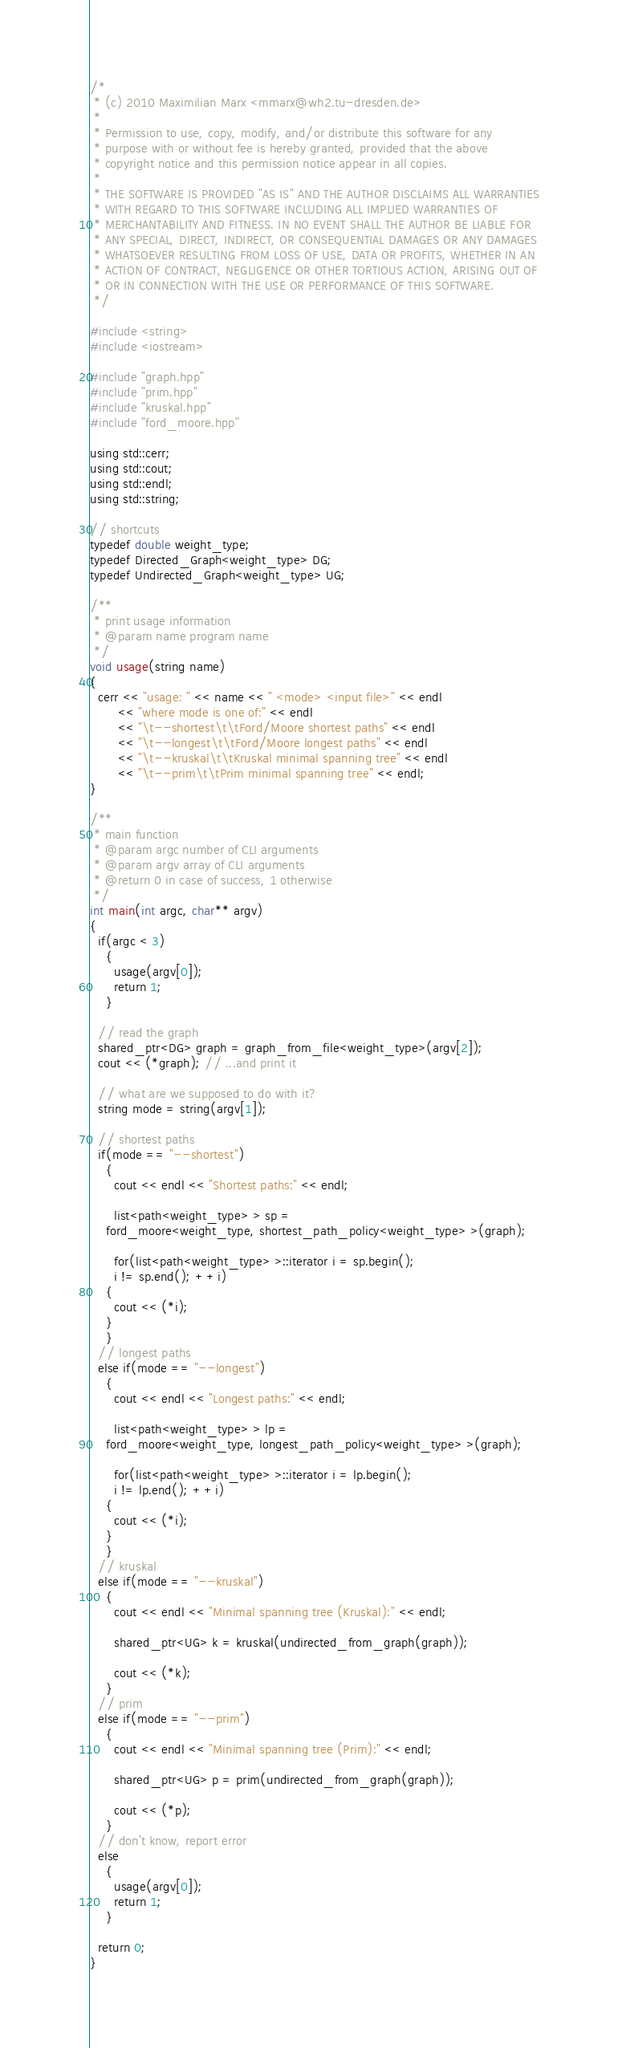<code> <loc_0><loc_0><loc_500><loc_500><_C++_>/*
 * (c) 2010 Maximilian Marx <mmarx@wh2.tu-dresden.de>
 *
 * Permission to use, copy, modify, and/or distribute this software for any
 * purpose with or without fee is hereby granted, provided that the above
 * copyright notice and this permission notice appear in all copies.
 *
 * THE SOFTWARE IS PROVIDED "AS IS" AND THE AUTHOR DISCLAIMS ALL WARRANTIES
 * WITH REGARD TO THIS SOFTWARE INCLUDING ALL IMPLIED WARRANTIES OF
 * MERCHANTABILITY AND FITNESS. IN NO EVENT SHALL THE AUTHOR BE LIABLE FOR
 * ANY SPECIAL, DIRECT, INDIRECT, OR CONSEQUENTIAL DAMAGES OR ANY DAMAGES
 * WHATSOEVER RESULTING FROM LOSS OF USE, DATA OR PROFITS, WHETHER IN AN
 * ACTION OF CONTRACT, NEGLIGENCE OR OTHER TORTIOUS ACTION, ARISING OUT OF
 * OR IN CONNECTION WITH THE USE OR PERFORMANCE OF THIS SOFTWARE.
 */

#include <string>
#include <iostream>

#include "graph.hpp"
#include "prim.hpp"
#include "kruskal.hpp"
#include "ford_moore.hpp"

using std::cerr;
using std::cout;
using std::endl;
using std::string;

// shortcuts
typedef double weight_type;
typedef Directed_Graph<weight_type> DG;
typedef Undirected_Graph<weight_type> UG;

/**
 * print usage information
 * @param name program name
 */
void usage(string name)
{
  cerr << "usage: " << name << " <mode> <input file>" << endl
       << "where mode is one of:" << endl
       << "\t--shortest\t\tFord/Moore shortest paths" << endl
       << "\t--longest\t\tFord/Moore longest paths" << endl
       << "\t--kruskal\t\tKruskal minimal spanning tree" << endl
       << "\t--prim\t\tPrim minimal spanning tree" << endl;
}

/**
 * main function
 * @param argc number of CLI arguments
 * @param argv array of CLI arguments
 * @return 0 in case of success, 1 otherwise
 */
int main(int argc, char** argv)
{
  if(argc < 3)
    {
      usage(argv[0]);
      return 1;
    }

  // read the graph
  shared_ptr<DG> graph = graph_from_file<weight_type>(argv[2]);
  cout << (*graph); // ...and print it

  // what are we supposed to do with it?
  string mode = string(argv[1]);

  // shortest paths
  if(mode == "--shortest")
    {
      cout << endl << "Shortest paths:" << endl;

      list<path<weight_type> > sp =
	ford_moore<weight_type, shortest_path_policy<weight_type> >(graph);

      for(list<path<weight_type> >::iterator i = sp.begin();
	  i != sp.end(); ++i)
	{
	  cout << (*i);
	}
    }
  // longest paths
  else if(mode == "--longest")
    {
      cout << endl << "Longest paths:" << endl;

      list<path<weight_type> > lp =
	ford_moore<weight_type, longest_path_policy<weight_type> >(graph);

      for(list<path<weight_type> >::iterator i = lp.begin();
	  i != lp.end(); ++i)
	{
	  cout << (*i);
	}
    }
  // kruskal
  else if(mode == "--kruskal")
    {
      cout << endl << "Minimal spanning tree (Kruskal):" << endl;

      shared_ptr<UG> k = kruskal(undirected_from_graph(graph));

      cout << (*k);
    }
  // prim
  else if(mode == "--prim")
    {
      cout << endl << "Minimal spanning tree (Prim):" << endl;

      shared_ptr<UG> p = prim(undirected_from_graph(graph));

      cout << (*p);
    }
  // don't know, report error
  else
    {
      usage(argv[0]);
      return 1;
    }

  return 0;
}
</code> 